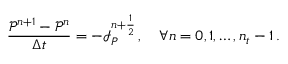<formula> <loc_0><loc_0><loc_500><loc_500>\frac { \mathcal { P } ^ { n + 1 } - \mathcal { P } ^ { n } } { \Delta t } = - \mathcal { I } _ { P } ^ { n + \frac { 1 } { 2 } } \, , \quad \forall n = 0 , 1 , \hdots , n _ { t } - 1 \, .</formula> 